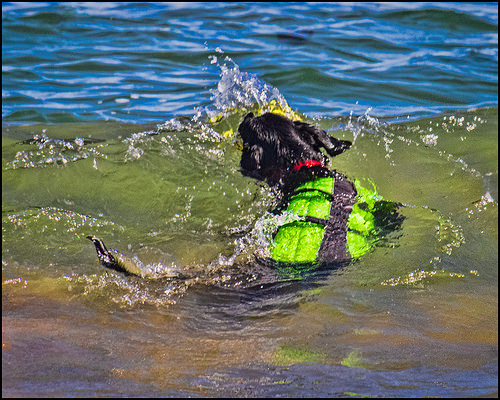<image>
Is the dog on the collar? No. The dog is not positioned on the collar. They may be near each other, but the dog is not supported by or resting on top of the collar. 